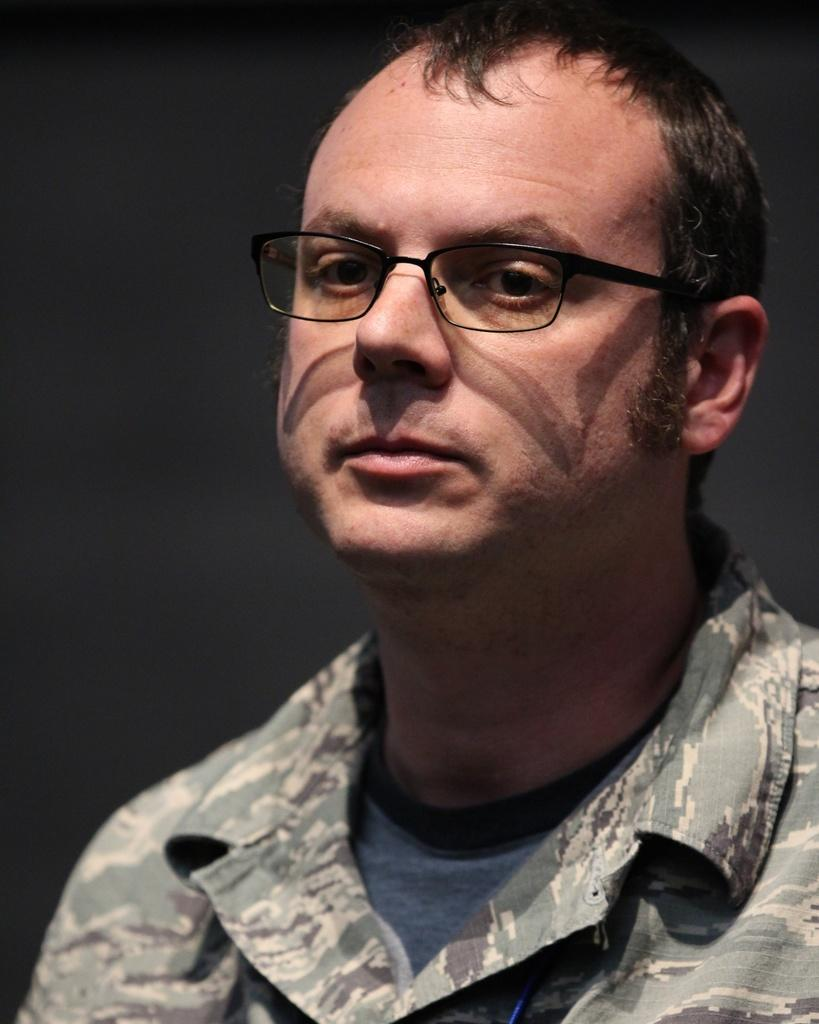What is present in the image? There is a person in the image. What is the person wearing on their upper body? The person is wearing a shirt and a T-shirt. What accessory is the person wearing on their face? The person is wearing spectacles. What can be observed about the background of the image? The background of the image is dark. How much money is the person holding in the image? There is no indication in the image that the person is holding money. 